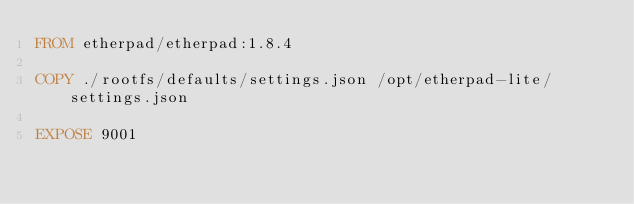Convert code to text. <code><loc_0><loc_0><loc_500><loc_500><_Dockerfile_>FROM etherpad/etherpad:1.8.4

COPY ./rootfs/defaults/settings.json /opt/etherpad-lite/settings.json

EXPOSE 9001
</code> 